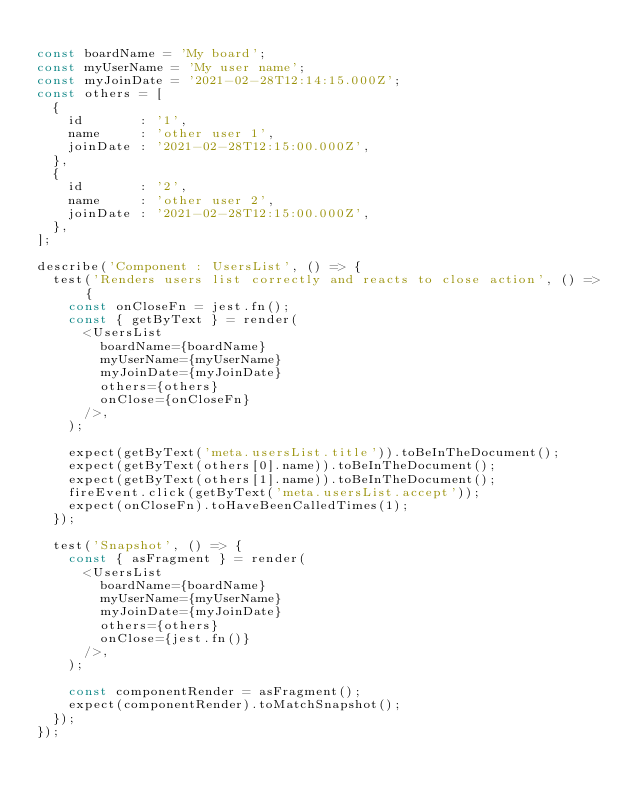<code> <loc_0><loc_0><loc_500><loc_500><_JavaScript_>
const boardName = 'My board';
const myUserName = 'My user name';
const myJoinDate = '2021-02-28T12:14:15.000Z';
const others = [
  {
    id       : '1',
    name     : 'other user 1',
    joinDate : '2021-02-28T12:15:00.000Z',
  },
  {
    id       : '2',
    name     : 'other user 2',
    joinDate : '2021-02-28T12:15:00.000Z',
  },
];

describe('Component : UsersList', () => {
  test('Renders users list correctly and reacts to close action', () => {
    const onCloseFn = jest.fn();
    const { getByText } = render(
      <UsersList
        boardName={boardName}
        myUserName={myUserName}
        myJoinDate={myJoinDate}
        others={others}
        onClose={onCloseFn}
      />,
    );

    expect(getByText('meta.usersList.title')).toBeInTheDocument();
    expect(getByText(others[0].name)).toBeInTheDocument();
    expect(getByText(others[1].name)).toBeInTheDocument();
    fireEvent.click(getByText('meta.usersList.accept'));
    expect(onCloseFn).toHaveBeenCalledTimes(1);
  });

  test('Snapshot', () => {
    const { asFragment } = render(
      <UsersList
        boardName={boardName}
        myUserName={myUserName}
        myJoinDate={myJoinDate}
        others={others}
        onClose={jest.fn()}
      />,
    );

    const componentRender = asFragment();
    expect(componentRender).toMatchSnapshot();
  });
});
</code> 